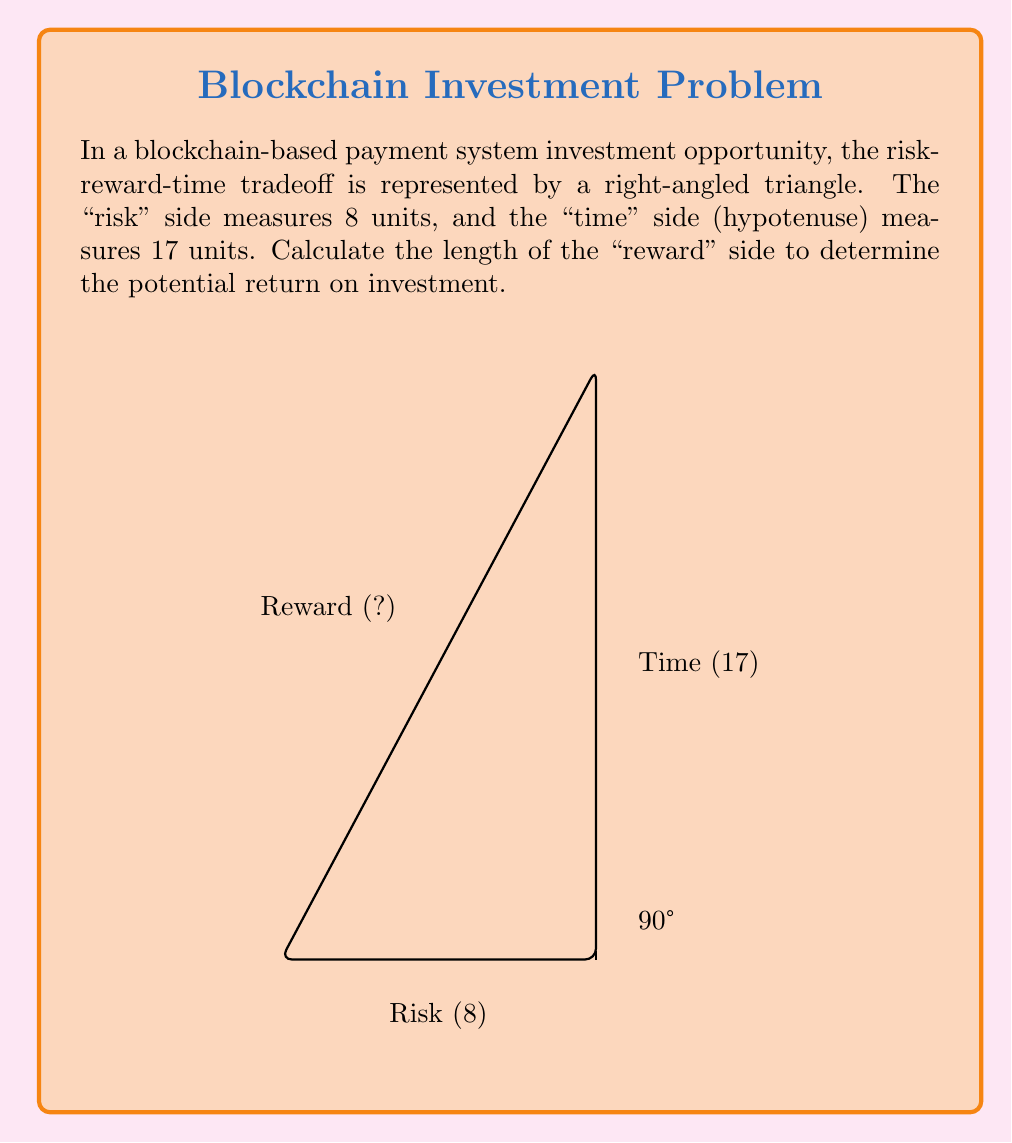Help me with this question. To solve this problem, we'll use the Pythagorean theorem, which states that in a right-angled triangle, the square of the hypotenuse is equal to the sum of squares of the other two sides.

Let's define our variables:
- Risk side: $a = 8$
- Time side (hypotenuse): $c = 17$
- Reward side: $b$ (unknown)

Step 1: Apply the Pythagorean theorem
$$a^2 + b^2 = c^2$$

Step 2: Substitute the known values
$$8^2 + b^2 = 17^2$$

Step 3: Simplify
$$64 + b^2 = 289$$

Step 4: Isolate $b^2$
$$b^2 = 289 - 64 = 225$$

Step 5: Take the square root of both sides
$$b = \sqrt{225}$$

Step 6: Simplify the square root
$$b = 15$$

Therefore, the length of the "reward" side is 15 units, representing the potential return on investment for this blockchain-based payment system opportunity.
Answer: 15 units 